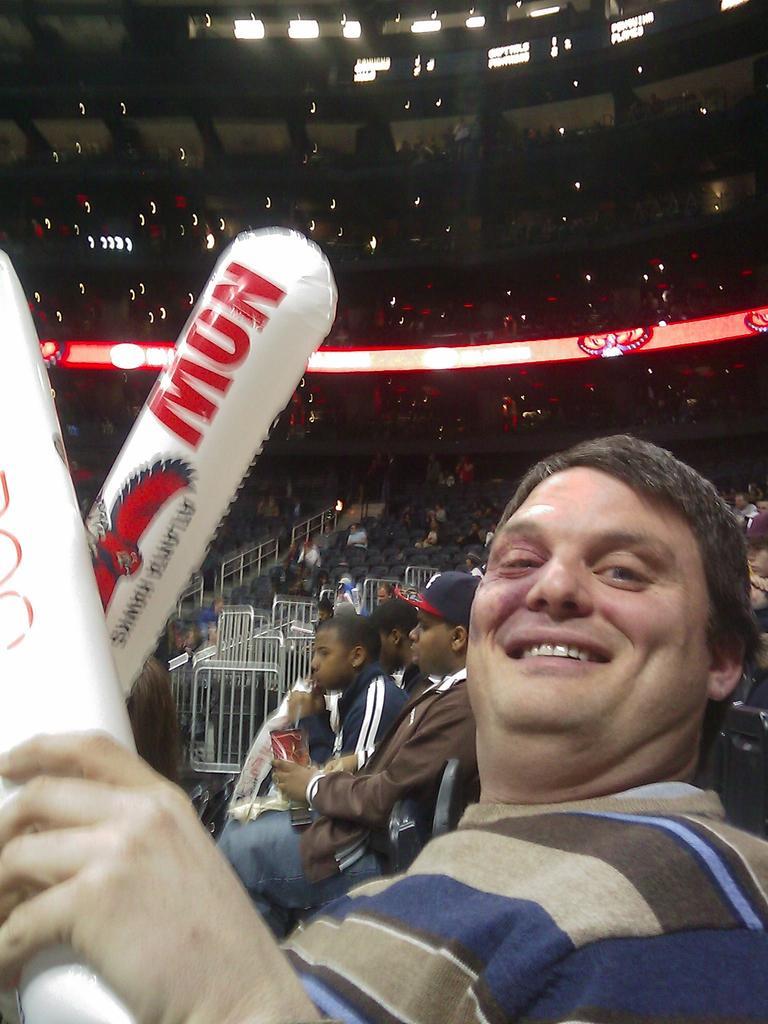Describe this image in one or two sentences. In the center of the image there is a person holding white color objects. There are people behind him. In the background of the image there are stands. There are railings. At the top of the image there are lights. 